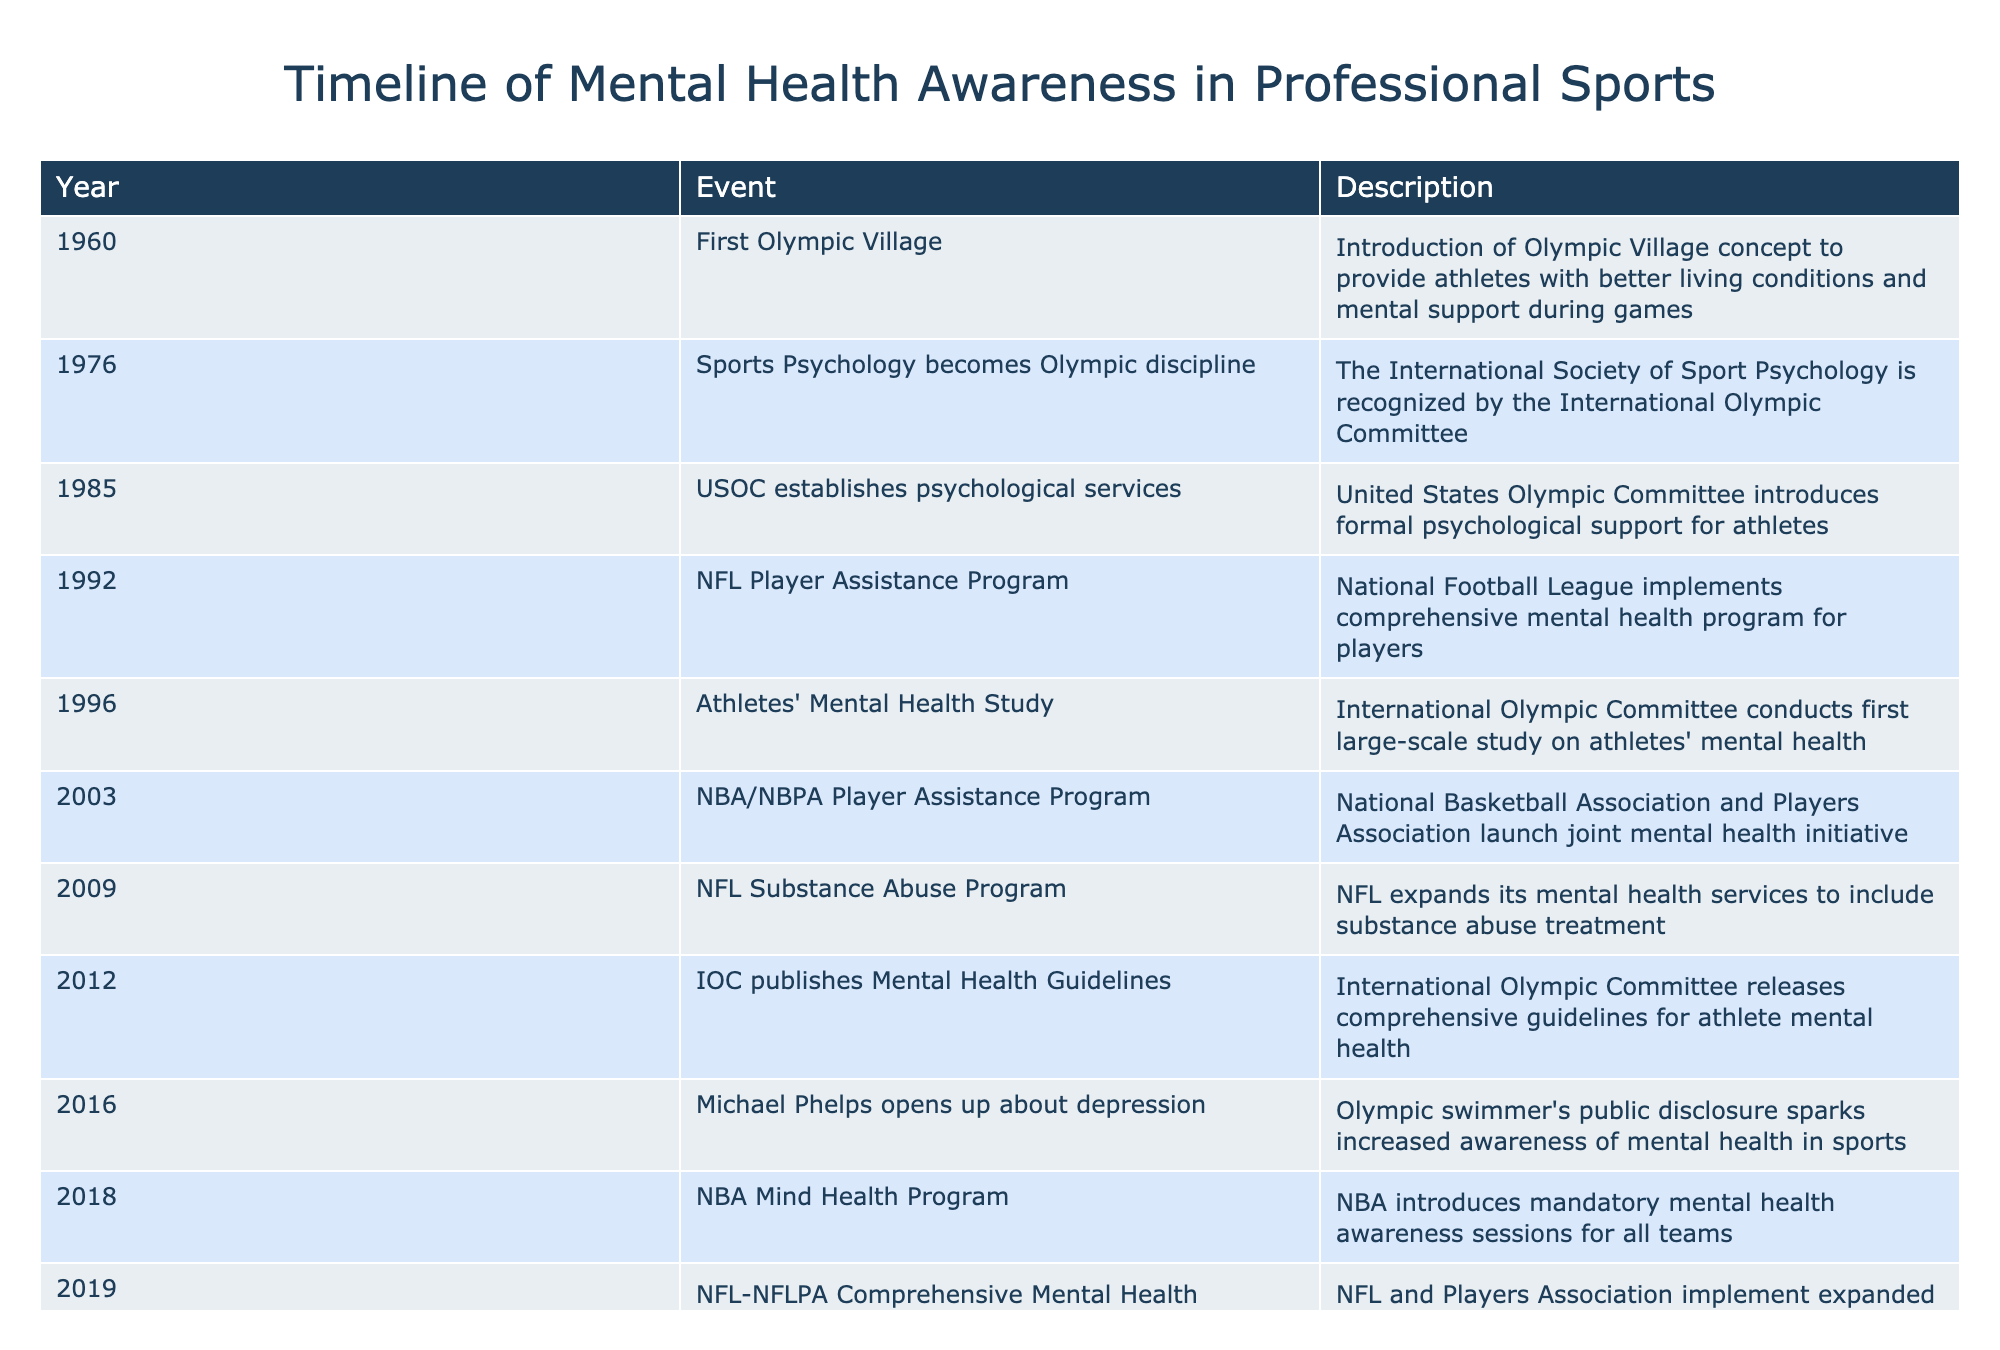What year did the NBA introduce mandatory mental health awareness sessions? According to the table, the NBA introduced mandatory mental health awareness sessions for all teams in 2018.
Answer: 2018 Which organization launched a joint mental health initiative in 2003? The National Basketball Association and Players Association launched the joint mental health initiative in 2003, as noted in the table.
Answer: NBA/NBPA How many significant mental health events occurred in the 2010s? The table lists six significant mental health events from 2010 to 2019: 2012 (IOC guidelines), 2016 (Phelps), 2018 (NBA program), 2019 (NFL program), and the events of 2020 and 2021, totaling six events.
Answer: 6 Was the formation of the Global Sports Mental Health Alliance in 2023 the first comprehensive initiative mentioned? No, the table shows that the first comprehensive initiative was the establishment of psychological services by the USOC in 1985, making it the earliest available formal support for athletes.
Answer: No What was the primary focus of the mental health initiatives introduced by the NFL in 2009? The table indicates that in 2009, the NFL expanded its mental health services to include substance abuse treatment, highlighting a focus on addressing substance abuse in addition to general mental health.
Answer: Substance abuse treatment List all the events that occurred in the 1990s related to mental health awareness in sports. The events in the table relevant to the 1990s are the NFL Player Assistance Program (1992) and the Athletes' Mental Health Study (1996), marking key advancements during that decade.
Answer: NFL Player Assistance Program, Athletes' Mental Health Study What is the key outcome of Simone Biles' withdrawal from the Olympics in 2021 regarding mental health? Simone Biles' decision to withdraw from the Olympics in 2021 highlighted the importance of prioritizing mental health, which gained global attention and support, as noted in the table.
Answer: Increased awareness of mental health How many years passed between the introduction of the first Olympic Village concept and the establishment of psychological services by the USOC? The first Olympic Village concept was in 1960 and the USOC established psychological services in 1985. The difference is 1985 - 1960 = 25 years.
Answer: 25 years 